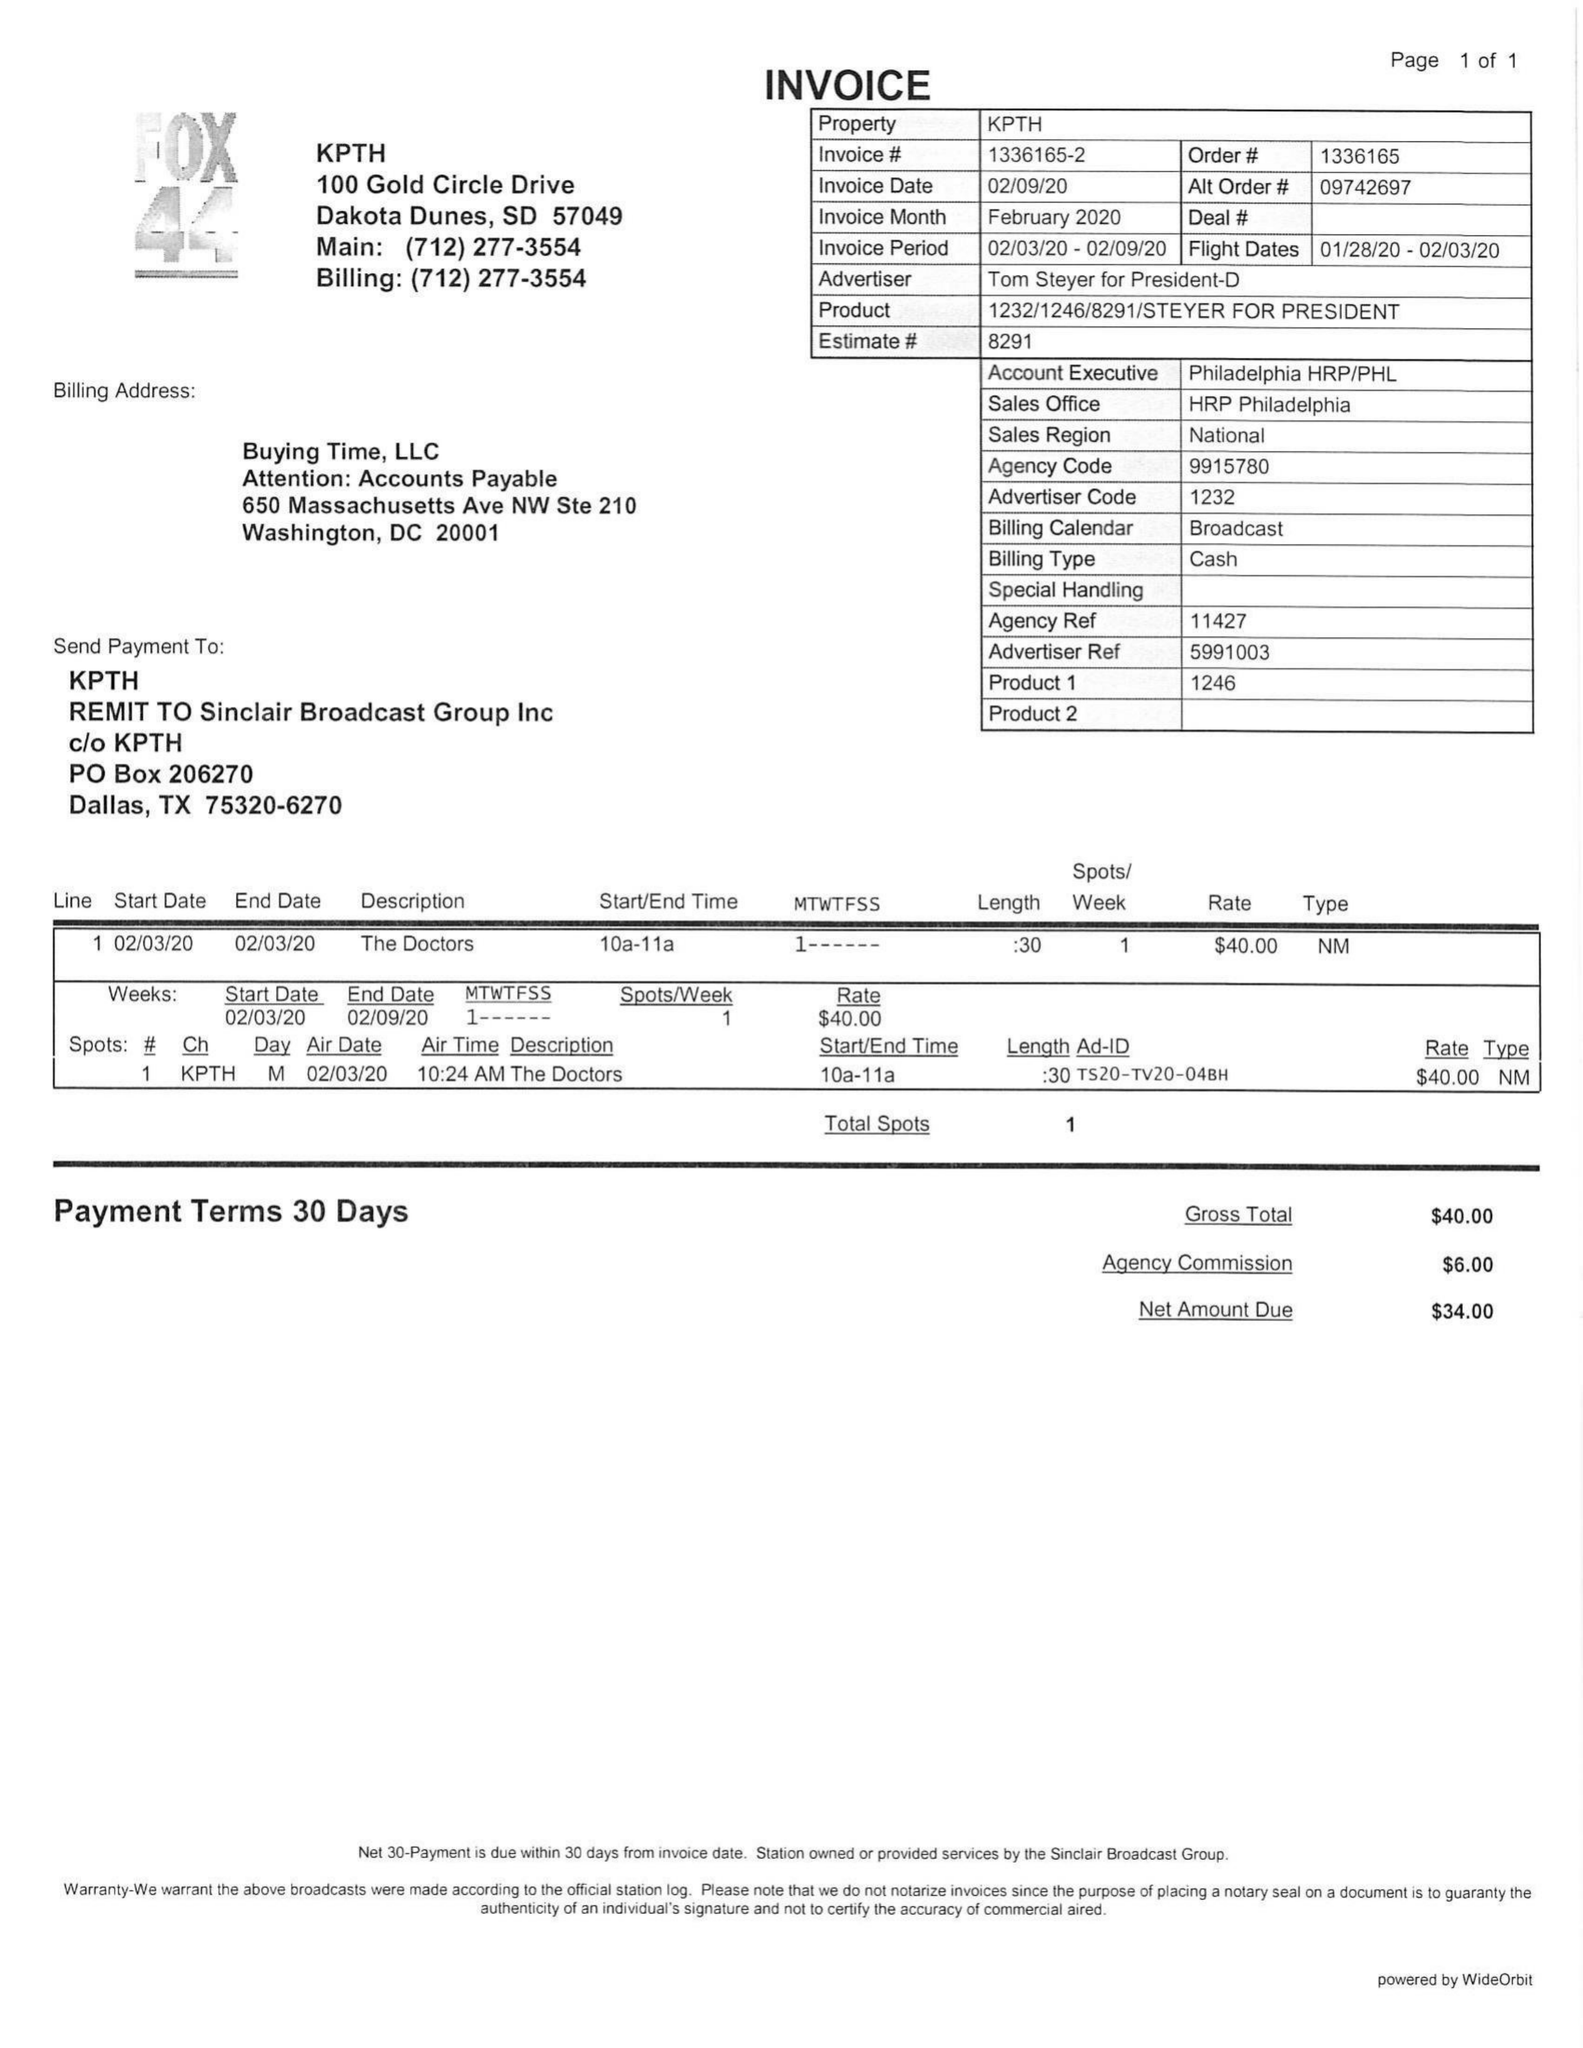What is the value for the flight_to?
Answer the question using a single word or phrase. 02/03/20 